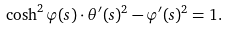<formula> <loc_0><loc_0><loc_500><loc_500>\cosh ^ { 2 } \varphi ( s ) \cdot \theta ^ { \prime } ( s ) ^ { 2 } - \varphi ^ { \prime } ( s ) ^ { 2 } = 1 .</formula> 